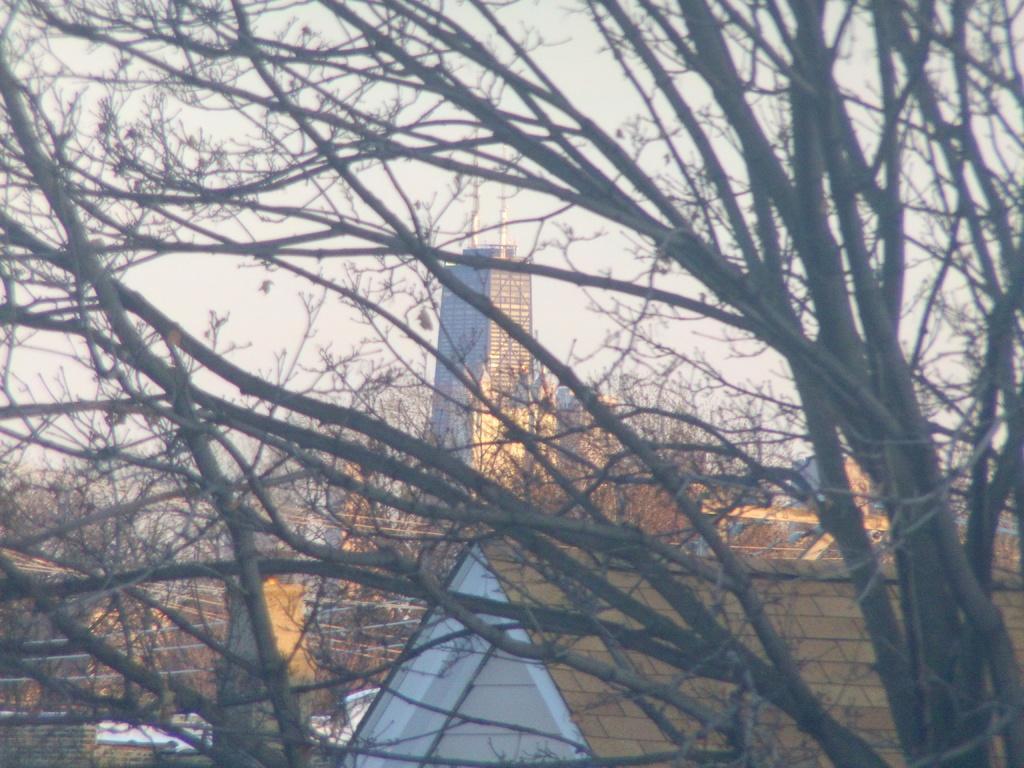How would you summarize this image in a sentence or two? In the foreground of the image there are tree branches. In the background of the image there is a building. There is a fencing. 